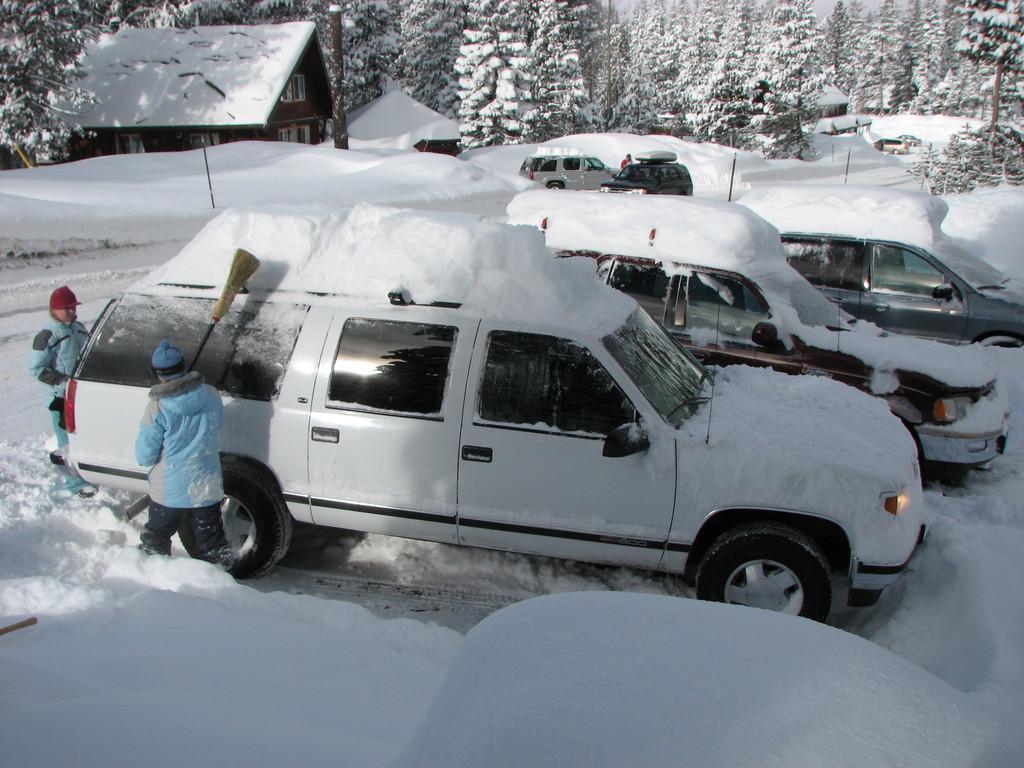How would you summarize this image in a sentence or two? In this image we can see motor vehicles on the ground, persons standing by holding brooms in their hands, buildings, trees and sky. 